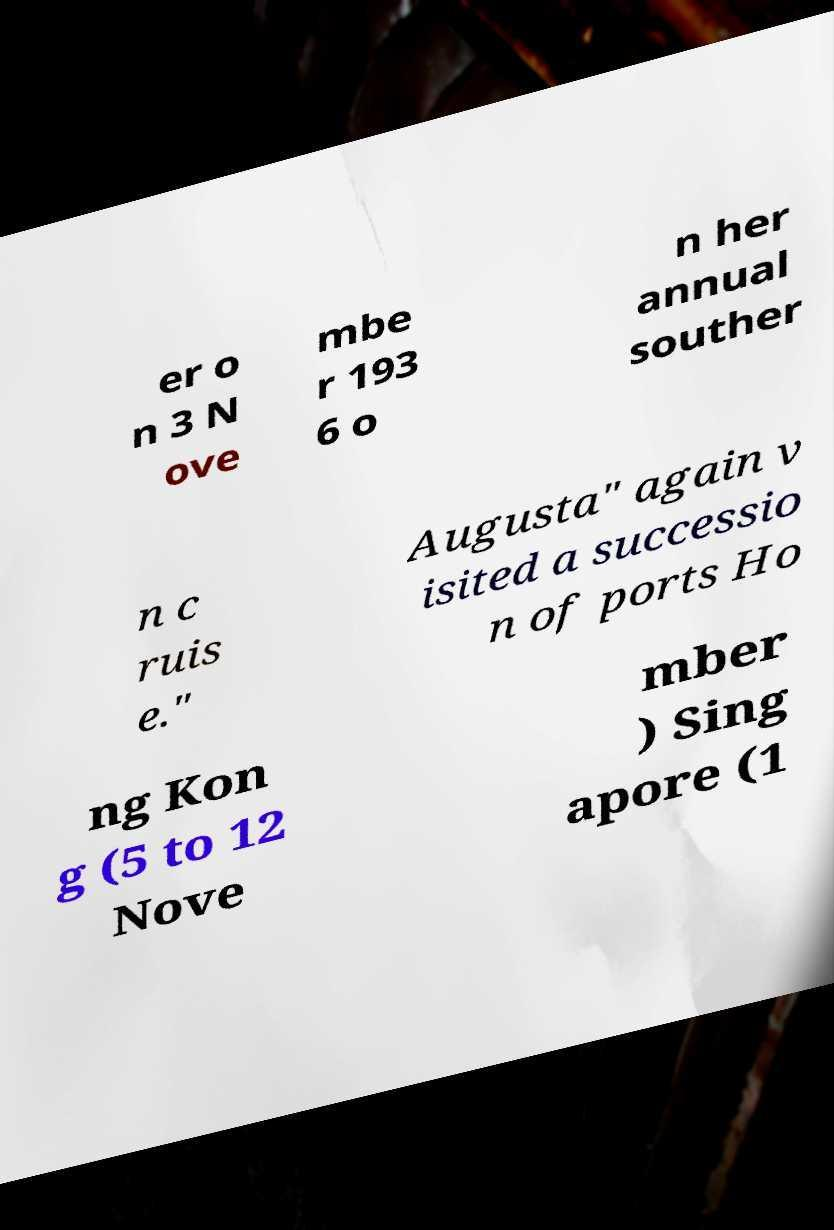Could you assist in decoding the text presented in this image and type it out clearly? er o n 3 N ove mbe r 193 6 o n her annual souther n c ruis e." Augusta" again v isited a successio n of ports Ho ng Kon g (5 to 12 Nove mber ) Sing apore (1 